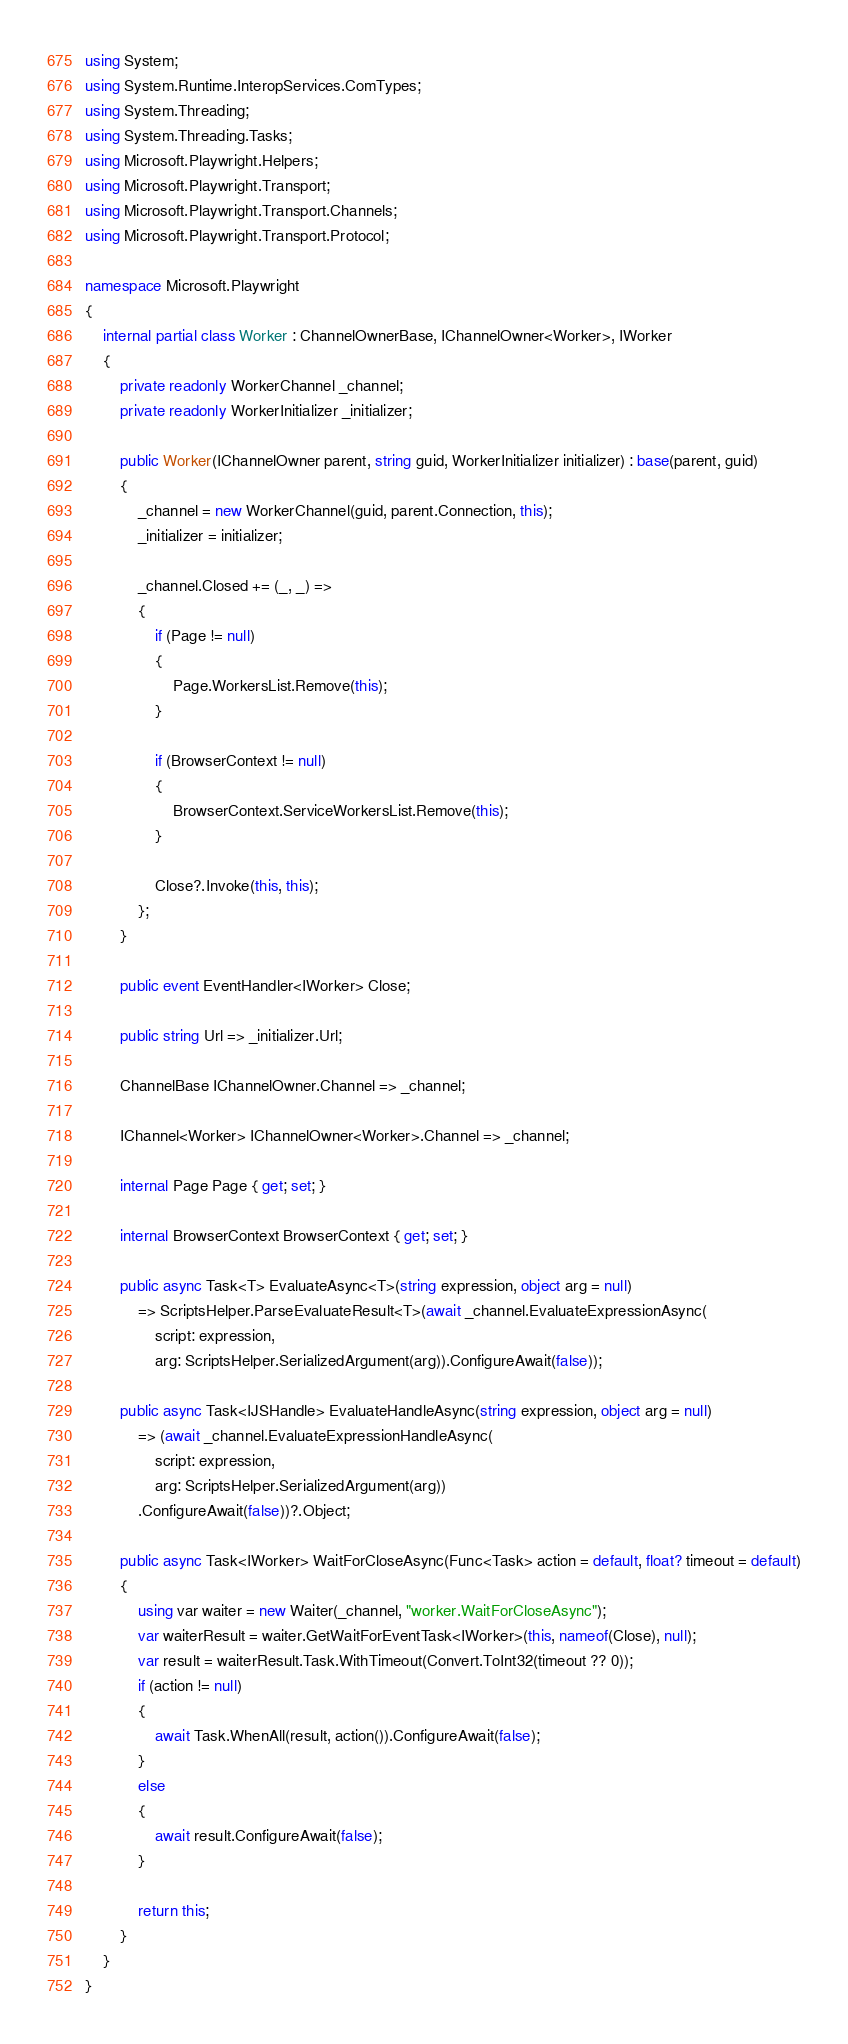Convert code to text. <code><loc_0><loc_0><loc_500><loc_500><_C#_>using System;
using System.Runtime.InteropServices.ComTypes;
using System.Threading;
using System.Threading.Tasks;
using Microsoft.Playwright.Helpers;
using Microsoft.Playwright.Transport;
using Microsoft.Playwright.Transport.Channels;
using Microsoft.Playwright.Transport.Protocol;

namespace Microsoft.Playwright
{
    internal partial class Worker : ChannelOwnerBase, IChannelOwner<Worker>, IWorker
    {
        private readonly WorkerChannel _channel;
        private readonly WorkerInitializer _initializer;

        public Worker(IChannelOwner parent, string guid, WorkerInitializer initializer) : base(parent, guid)
        {
            _channel = new WorkerChannel(guid, parent.Connection, this);
            _initializer = initializer;

            _channel.Closed += (_, _) =>
            {
                if (Page != null)
                {
                    Page.WorkersList.Remove(this);
                }

                if (BrowserContext != null)
                {
                    BrowserContext.ServiceWorkersList.Remove(this);
                }

                Close?.Invoke(this, this);
            };
        }

        public event EventHandler<IWorker> Close;

        public string Url => _initializer.Url;

        ChannelBase IChannelOwner.Channel => _channel;

        IChannel<Worker> IChannelOwner<Worker>.Channel => _channel;

        internal Page Page { get; set; }

        internal BrowserContext BrowserContext { get; set; }

        public async Task<T> EvaluateAsync<T>(string expression, object arg = null)
            => ScriptsHelper.ParseEvaluateResult<T>(await _channel.EvaluateExpressionAsync(
                script: expression,
                arg: ScriptsHelper.SerializedArgument(arg)).ConfigureAwait(false));

        public async Task<IJSHandle> EvaluateHandleAsync(string expression, object arg = null)
            => (await _channel.EvaluateExpressionHandleAsync(
                script: expression,
                arg: ScriptsHelper.SerializedArgument(arg))
            .ConfigureAwait(false))?.Object;

        public async Task<IWorker> WaitForCloseAsync(Func<Task> action = default, float? timeout = default)
        {
            using var waiter = new Waiter(_channel, "worker.WaitForCloseAsync");
            var waiterResult = waiter.GetWaitForEventTask<IWorker>(this, nameof(Close), null);
            var result = waiterResult.Task.WithTimeout(Convert.ToInt32(timeout ?? 0));
            if (action != null)
            {
                await Task.WhenAll(result, action()).ConfigureAwait(false);
            }
            else
            {
                await result.ConfigureAwait(false);
            }

            return this;
        }
    }
}
</code> 